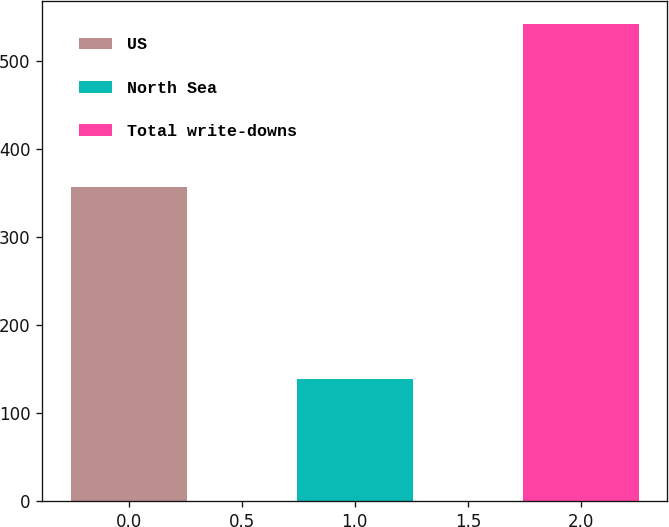Convert chart. <chart><loc_0><loc_0><loc_500><loc_500><bar_chart><fcel>US<fcel>North Sea<fcel>Total write-downs<nl><fcel>356<fcel>139<fcel>541<nl></chart> 